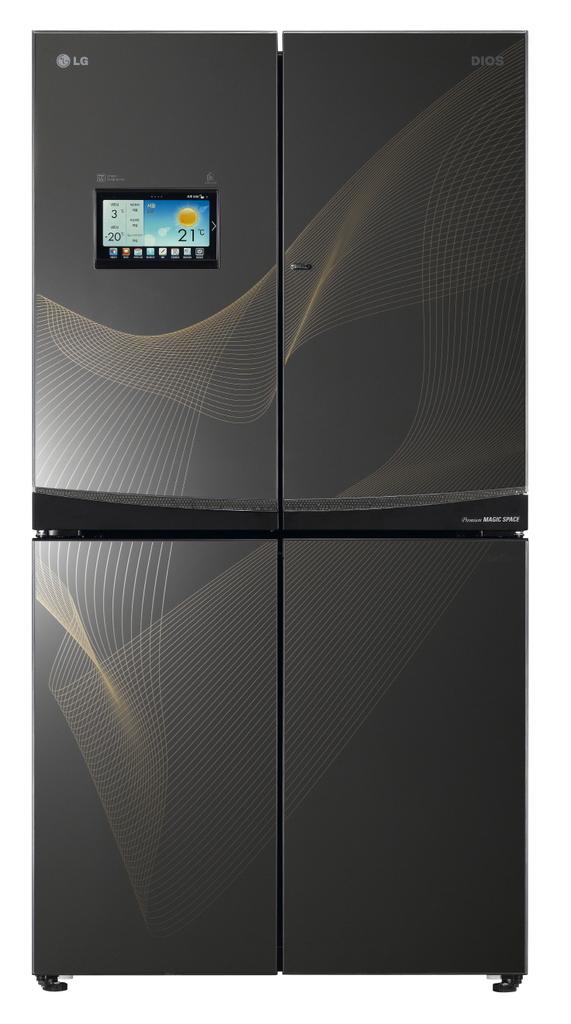What is the temperature?
Your answer should be compact. 21 degrees celsius. 